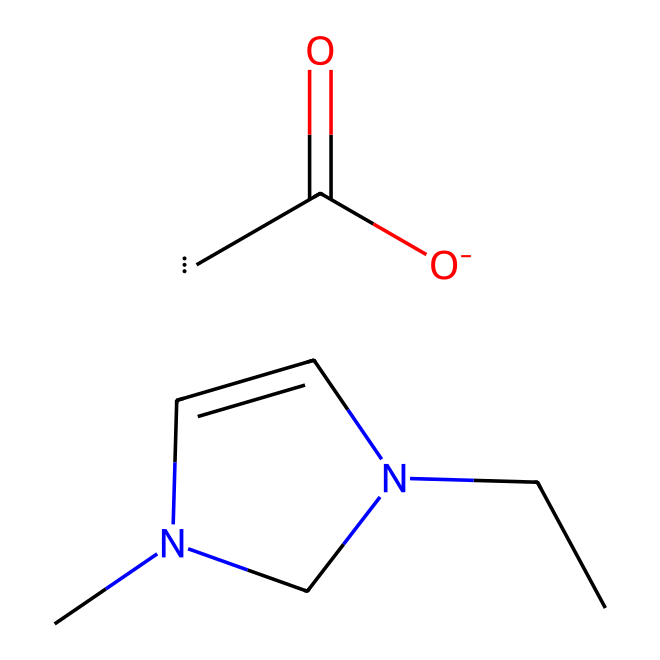What is the total number of carbon atoms in 1-ethyl-3-methylimidazolium acetate? By examining the SMILES representation, CCN1C=CN(C)C1 represents the ethyl and methyl groups along with the imidazolium ring (which contributes three carbon atoms), and there is an additional carbon from the acetate part, giving a total count of six.
Answer: six How many nitrogen atoms are present in this ionic liquid? In the SMILES notation, the nitrogen atoms are represented by 'N' and can be counted in the imidazolium structure. There are two nitrogen atoms present, as indicated by their occurrences in the structure.
Answer: two What functional group is present in 1-ethyl-3-methylimidazolium acetate? Analyzing the acetate portion of the SMILES structure, C(=O)[O-] indicates the presence of a carboxylate functional group. This is fundamental in identifying the ionic nature of the liquid.
Answer: carboxylate Is 1-ethyl-3-methylimidazolium acetate a solid, liquid, or gas at room temperature? Ionic liquids like 1-ethyl-3-methylimidazolium acetate, due to their unique ionic bonding and low vapor pressures, remain liquid at room temperature, which is a characteristic feature of this class of compounds.
Answer: liquid What type of bonding primarily characterizes ionic liquids such as 1-ethyl-3-methylimidazolium acetate? The presence of charged species in ionic liquids, such as the imidazolium cation and the acetate anion, indicates that this compound primarily exhibits ionic bonding, which is a defining characteristic of ionic liquids.
Answer: ionic What role does the imidazolium ring play in this ionic liquid? The imidazolium ring provides the cationic component necessary for the ionic nature of this liquid. It enhances the stability and solvation properties, making it suitable for applications like cellulose processing.
Answer: cationic component What is the main application of 1-ethyl-3-methylimidazolium acetate? This ionic liquid is primarily used in biomass conversion, specifically in the processing of cellulose. Its unique properties make it effective in dissolving and modifying cellulose, facilitating various chemical reactions.
Answer: cellulose processing 